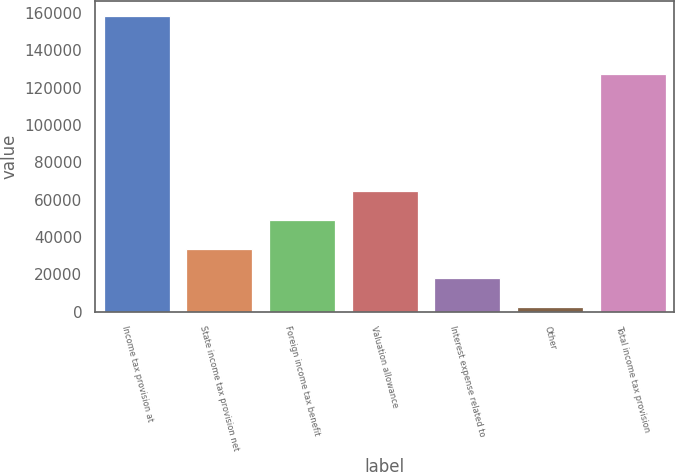<chart> <loc_0><loc_0><loc_500><loc_500><bar_chart><fcel>Income tax provision at<fcel>State income tax provision net<fcel>Foreign income tax benefit<fcel>Valuation allowance<fcel>Interest expense related to<fcel>Other<fcel>Total income tax provision<nl><fcel>158452<fcel>33462.4<fcel>49086.1<fcel>64709.8<fcel>17838.7<fcel>2215<fcel>127521<nl></chart> 